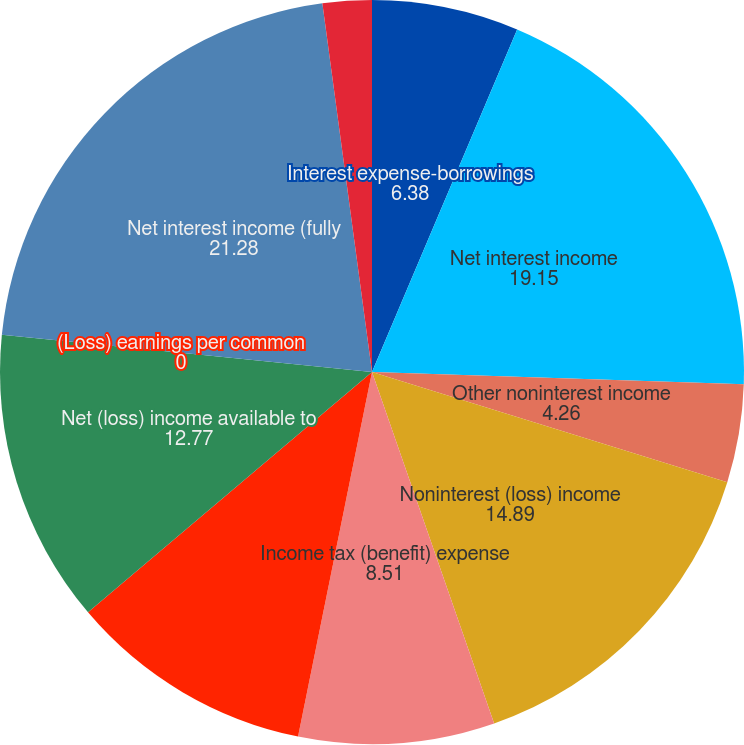Convert chart to OTSL. <chart><loc_0><loc_0><loc_500><loc_500><pie_chart><fcel>Interest expense-borrowings<fcel>Net interest income<fcel>Other noninterest income<fcel>Noninterest (loss) income<fcel>Income tax (benefit) expense<fcel>Net (loss) income attributable<fcel>Net (loss) income available to<fcel>(Loss) earnings per common<fcel>Net interest income (fully<fcel>Net interest margin<nl><fcel>6.38%<fcel>19.15%<fcel>4.26%<fcel>14.89%<fcel>8.51%<fcel>10.64%<fcel>12.77%<fcel>0.0%<fcel>21.28%<fcel>2.13%<nl></chart> 